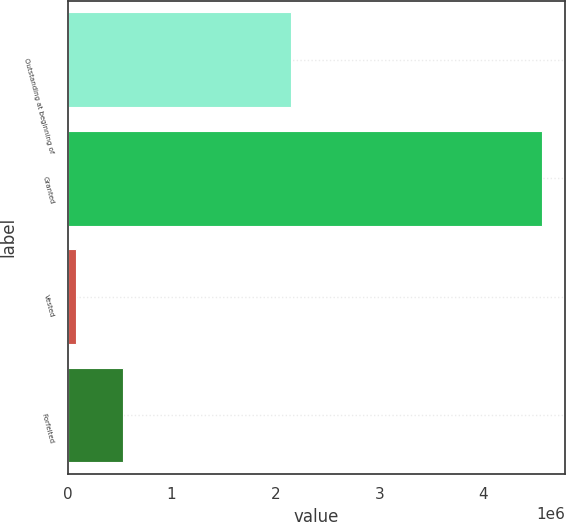Convert chart. <chart><loc_0><loc_0><loc_500><loc_500><bar_chart><fcel>Outstanding at beginning of<fcel>Granted<fcel>Vested<fcel>Forfeited<nl><fcel>2.15402e+06<fcel>4.5635e+06<fcel>83444<fcel>531449<nl></chart> 